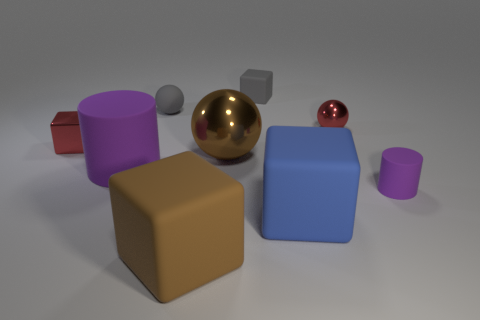There is a large brown shiny ball; how many purple things are left of it?
Make the answer very short. 1. What number of things are metal things that are on the left side of the matte sphere or small cyan metal things?
Your answer should be compact. 1. Are there more large brown matte things on the left side of the brown rubber block than large brown things that are behind the gray block?
Your response must be concise. No. There is a thing that is the same color as the small metal block; what is its size?
Keep it short and to the point. Small. There is a red shiny block; does it have the same size as the brown block that is right of the small metallic block?
Make the answer very short. No. What number of cylinders are large gray matte objects or small metal objects?
Give a very brief answer. 0. The brown thing that is the same material as the tiny red block is what size?
Provide a succinct answer. Large. Do the matte block on the left side of the gray cube and the purple object that is on the left side of the brown metal sphere have the same size?
Provide a succinct answer. Yes. What number of things are either small metal spheres or shiny cubes?
Provide a short and direct response. 2. The large brown shiny thing has what shape?
Your answer should be compact. Sphere. 